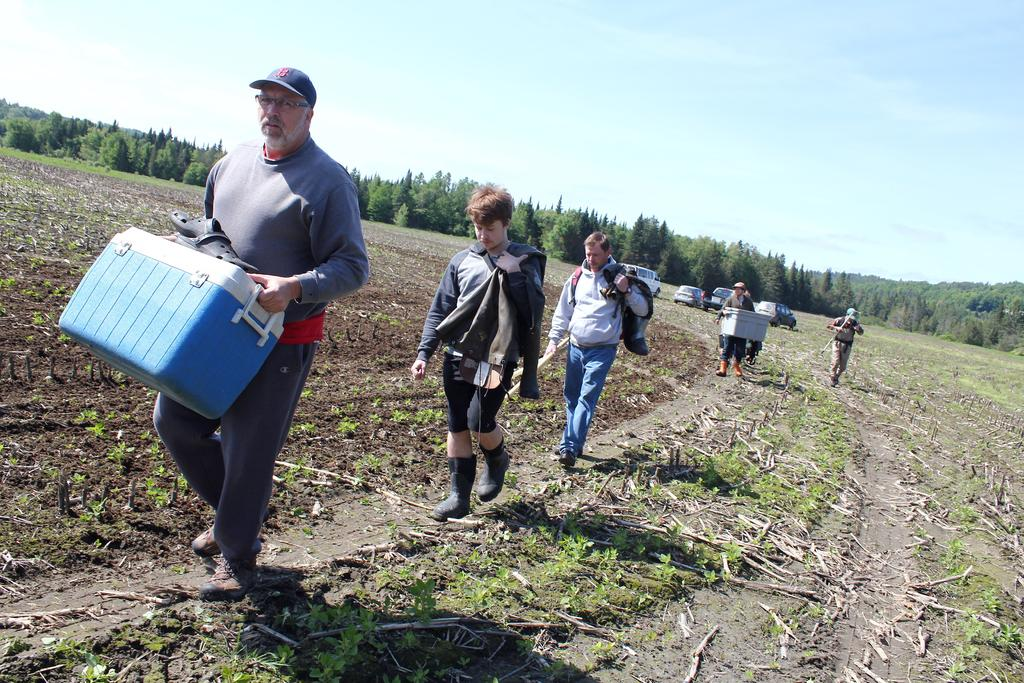What is the man on the left side of the image holding? The man is holding an ice box on the left side of the image. What is happening in the background of the image? There are people walking in the background of the image. What type of vegetation can be seen in the background of the image? There are trees in the background of the image. What is visible at the top of the image? The sky is visible at the top of the image. What type of wool is being spun by the queen in the image? There is no queen or wool present in the image. 